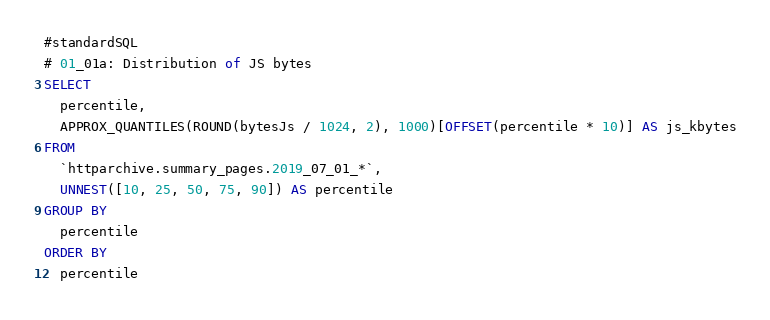Convert code to text. <code><loc_0><loc_0><loc_500><loc_500><_SQL_>#standardSQL
# 01_01a: Distribution of JS bytes
SELECT
  percentile,
  APPROX_QUANTILES(ROUND(bytesJs / 1024, 2), 1000)[OFFSET(percentile * 10)] AS js_kbytes
FROM
  `httparchive.summary_pages.2019_07_01_*`,
  UNNEST([10, 25, 50, 75, 90]) AS percentile
GROUP BY
  percentile
ORDER BY
  percentile
</code> 